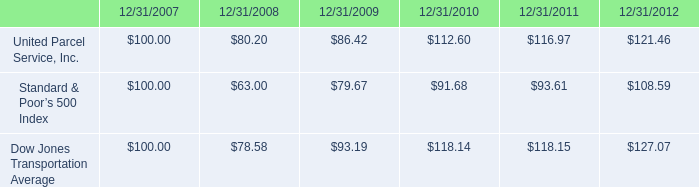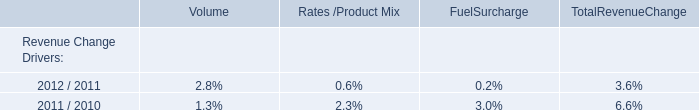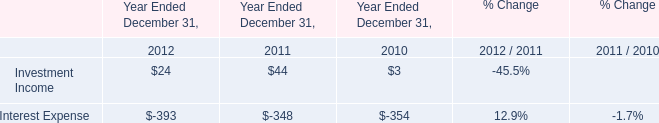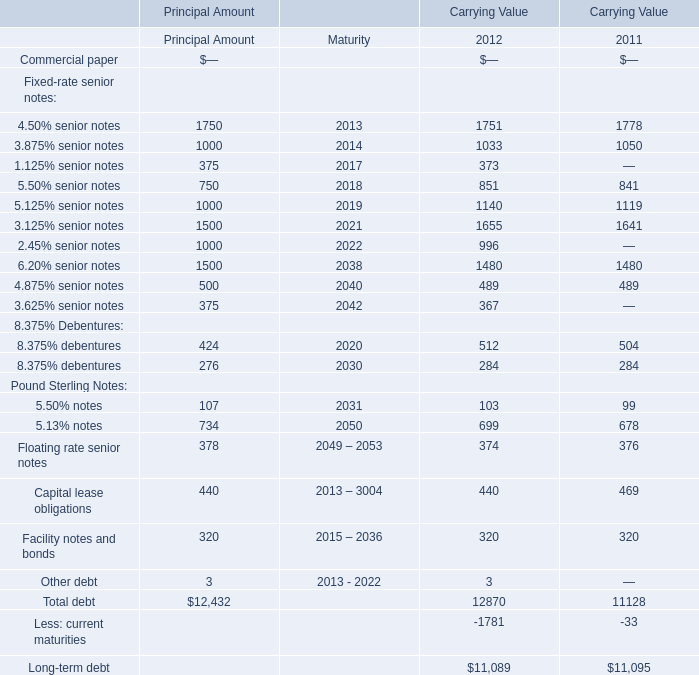what was the percentage total cumulative return on investment for united parcel service inc . for the five years ended 12/31/2012? 
Computations: ((121.46 - 100) / 100)
Answer: 0.2146. 